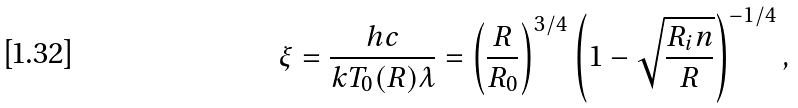Convert formula to latex. <formula><loc_0><loc_0><loc_500><loc_500>\xi = \frac { h c } { k T _ { 0 } ( R ) \lambda } = \left ( \frac { R } { R _ { 0 } } \right ) ^ { 3 / 4 } \left ( 1 - \sqrt { \frac { R _ { i } n } { R } } \right ) ^ { - 1 / 4 } ,</formula> 